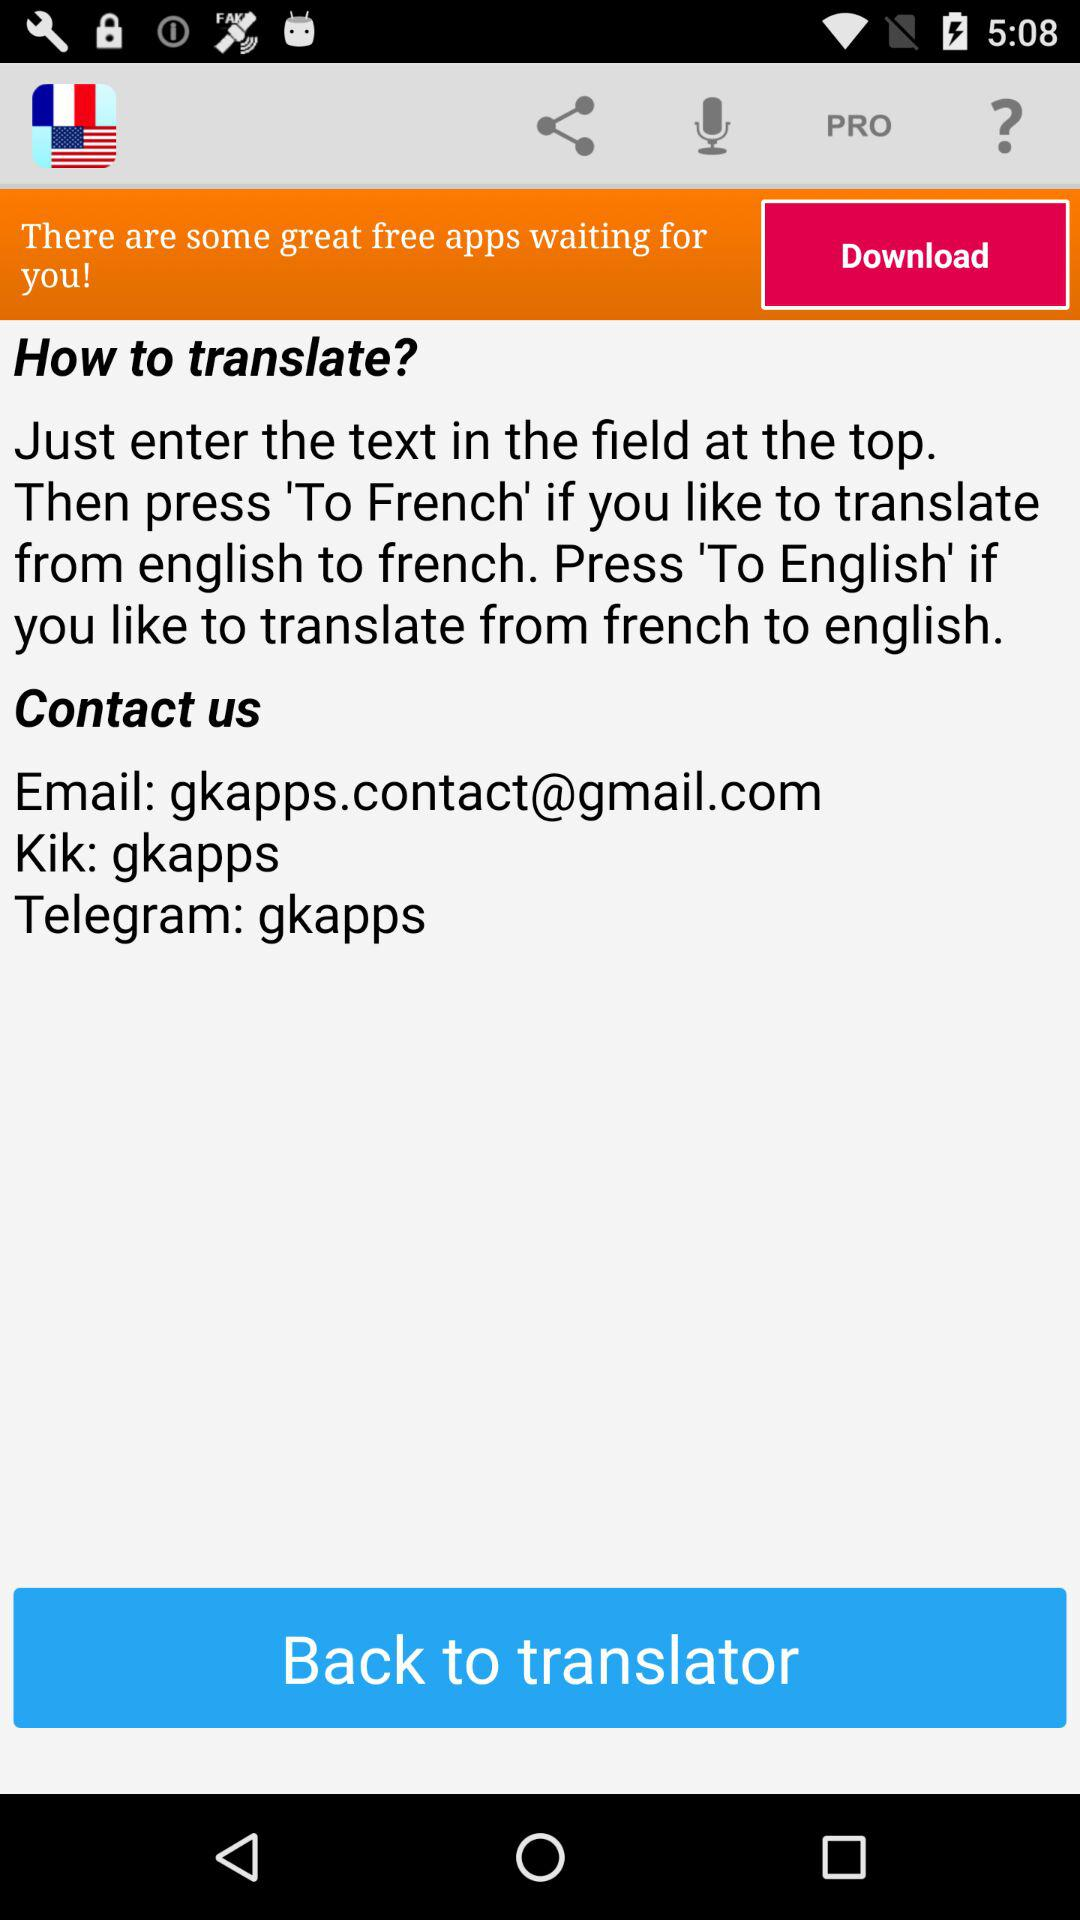How many options are available to translate to?
Answer the question using a single word or phrase. 2 